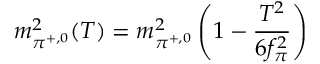<formula> <loc_0><loc_0><loc_500><loc_500>m _ { \pi ^ { + , 0 } } ^ { 2 } ( T ) = m _ { \pi ^ { + , 0 } } ^ { 2 } \left ( 1 - \frac { T ^ { 2 } } { 6 f _ { \pi } ^ { 2 } } \right )</formula> 